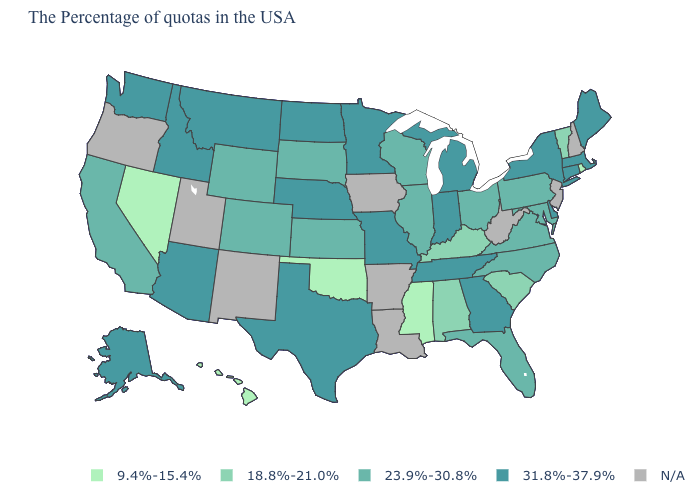Does the first symbol in the legend represent the smallest category?
Answer briefly. Yes. Does Rhode Island have the lowest value in the USA?
Answer briefly. Yes. What is the value of Vermont?
Give a very brief answer. 18.8%-21.0%. Does Illinois have the lowest value in the MidWest?
Concise answer only. Yes. Name the states that have a value in the range N/A?
Write a very short answer. New Hampshire, New Jersey, West Virginia, Louisiana, Arkansas, Iowa, New Mexico, Utah, Oregon. Name the states that have a value in the range 31.8%-37.9%?
Answer briefly. Maine, Massachusetts, Connecticut, New York, Delaware, Georgia, Michigan, Indiana, Tennessee, Missouri, Minnesota, Nebraska, Texas, North Dakota, Montana, Arizona, Idaho, Washington, Alaska. Name the states that have a value in the range 31.8%-37.9%?
Answer briefly. Maine, Massachusetts, Connecticut, New York, Delaware, Georgia, Michigan, Indiana, Tennessee, Missouri, Minnesota, Nebraska, Texas, North Dakota, Montana, Arizona, Idaho, Washington, Alaska. Which states hav the highest value in the West?
Give a very brief answer. Montana, Arizona, Idaho, Washington, Alaska. What is the value of Maryland?
Write a very short answer. 23.9%-30.8%. Among the states that border Nebraska , which have the lowest value?
Short answer required. Kansas, South Dakota, Wyoming, Colorado. Which states have the highest value in the USA?
Concise answer only. Maine, Massachusetts, Connecticut, New York, Delaware, Georgia, Michigan, Indiana, Tennessee, Missouri, Minnesota, Nebraska, Texas, North Dakota, Montana, Arizona, Idaho, Washington, Alaska. Among the states that border Maryland , does Delaware have the lowest value?
Short answer required. No. Name the states that have a value in the range 23.9%-30.8%?
Keep it brief. Maryland, Pennsylvania, Virginia, North Carolina, Ohio, Florida, Wisconsin, Illinois, Kansas, South Dakota, Wyoming, Colorado, California. Does Delaware have the highest value in the USA?
Be succinct. Yes. 